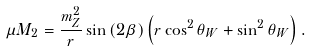<formula> <loc_0><loc_0><loc_500><loc_500>\mu M _ { 2 } = \frac { m _ { Z } ^ { 2 } } { r } \sin \left ( 2 \beta \right ) \left ( r \cos ^ { 2 } \theta _ { W } + \sin ^ { 2 } \theta _ { W } \right ) .</formula> 